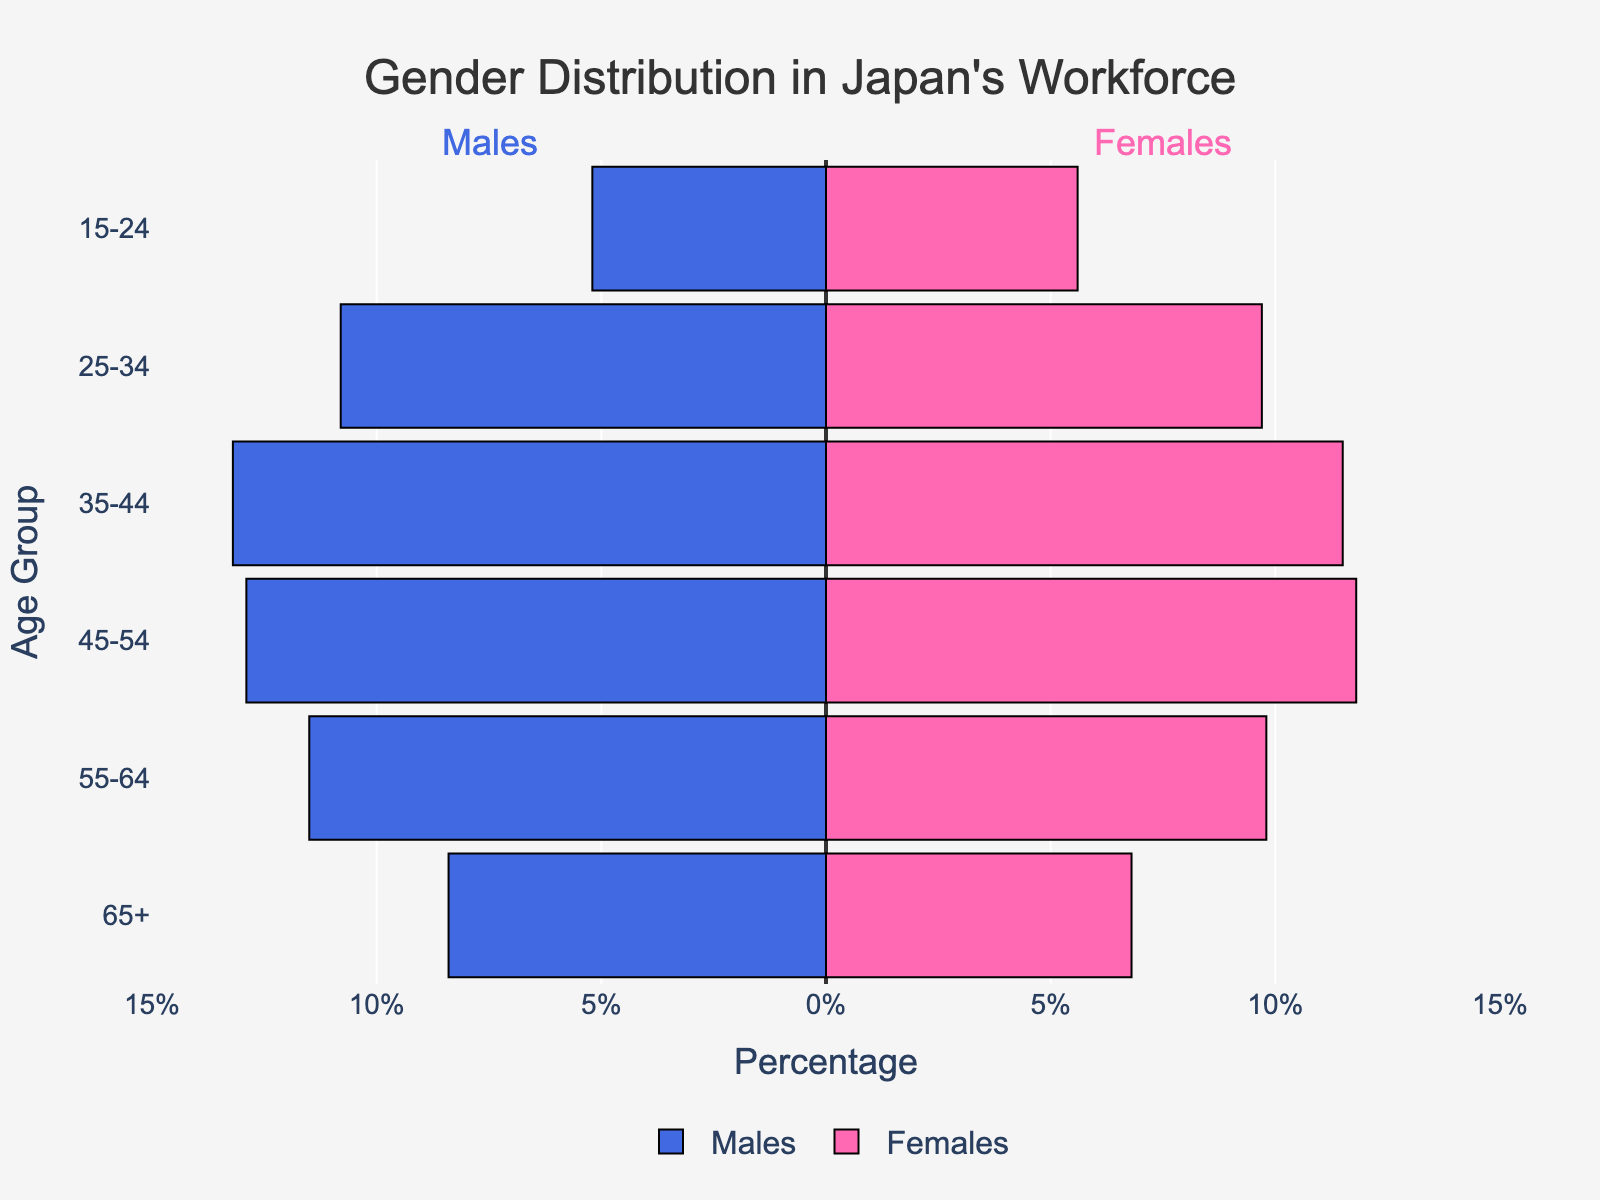Which age group has the highest percentage of males in the workforce? The figure shows the percentage distribution of males across different age groups. The 35-44 age group has the highest percentage of males, with 13.2%.
Answer: 35-44 Which age group has the lowest percentage of females in the workforce? By referring to the figure, the 65+ age group has the lowest percentage of females, at 6.8%.
Answer: 65+ What is the percentage difference between males and females in the 25-34 age group? The percentage of males in the 25-34 age group is 10.8%, while females are 9.7%. The difference is 10.8% - 9.7% = 1.1%.
Answer: 1.1% Which age group shows the smallest gender gap in workforce participation? To determine the smallest gender gap, we need to find the smallest percentage difference between males and females in each age group. In the 45-54 age group, the difference is 12.9% - 11.8% = 1.1%, which is the smallest gap.
Answer: 45-54 Compare the percentage of males and females in the workforce for the 55-64 age group. Which gender has a higher percentage? The percentage of males in the 55-64 age group is 11.5%, while females are 9.8%. Males have a higher percentage in this age group.
Answer: Males In which age group is the female workforce participation closest to the male participation? This involves comparing the percentage differences across all age groups. The smallest difference is in the 45-54 age group, with a difference of 1.1%, showing that female participation is closest to male participation in this group.
Answer: 45-54 What is the total percentage of the workforce in the 15-24 age group? Adding both male and female percentages: 5.2% (males) + 5.6% (females) = 10.8%.
Answer: 10.8% Which age group shows a wider gender gap in workforce participation, the 35-44 age group or the 65+ age group? The gap for the 35-44 age group is 13.2% (males) - 11.5% (females) = 1.7%. For the 65+ age group, the gap is 8.4% (males) - 6.8% (females) = 1.6%. The 35-44 age group has a wider gap.
Answer: 35-44 How does the gender distribution in the 15-24 age group compare to the 65+ age group? In the 15-24 age group, males are 5.2% and females 5.6%. In the 65+ age group, males are 8.4% and females 6.8%. While the male workforce percentage is higher in the 65+ group, the female percentage is higher in the 15-24 group.
Answer: Mixed, males higher in 65+, females higher in 15-24 What is the overall trend observed in the gender distribution of Japan's workforce across age groups? Generally, there is a higher percentage of males compared to females across all age groups. The participation peaks in the 35-44 age group for both genders and declines in older age groups.
Answer: Higher male participation, peaks in 35-44, declines in older groups 